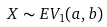Convert formula to latex. <formula><loc_0><loc_0><loc_500><loc_500>X \sim E V _ { 1 } ( a , b )</formula> 